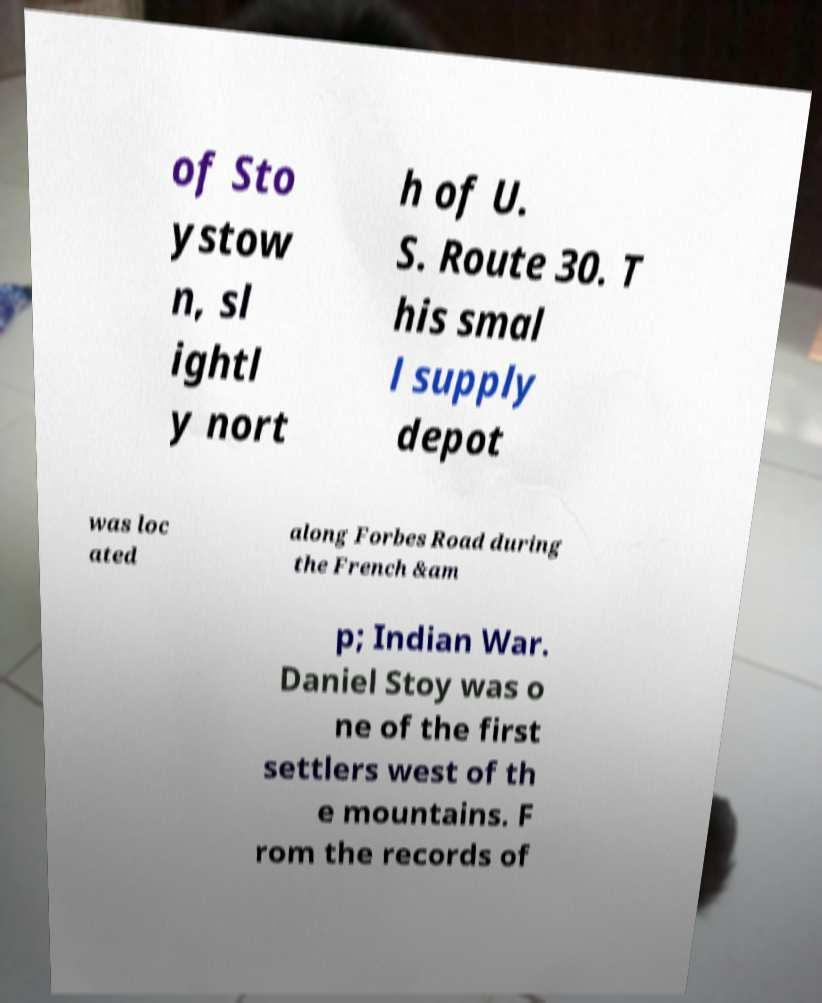Please read and relay the text visible in this image. What does it say? of Sto ystow n, sl ightl y nort h of U. S. Route 30. T his smal l supply depot was loc ated along Forbes Road during the French &am p; Indian War. Daniel Stoy was o ne of the first settlers west of th e mountains. F rom the records of 